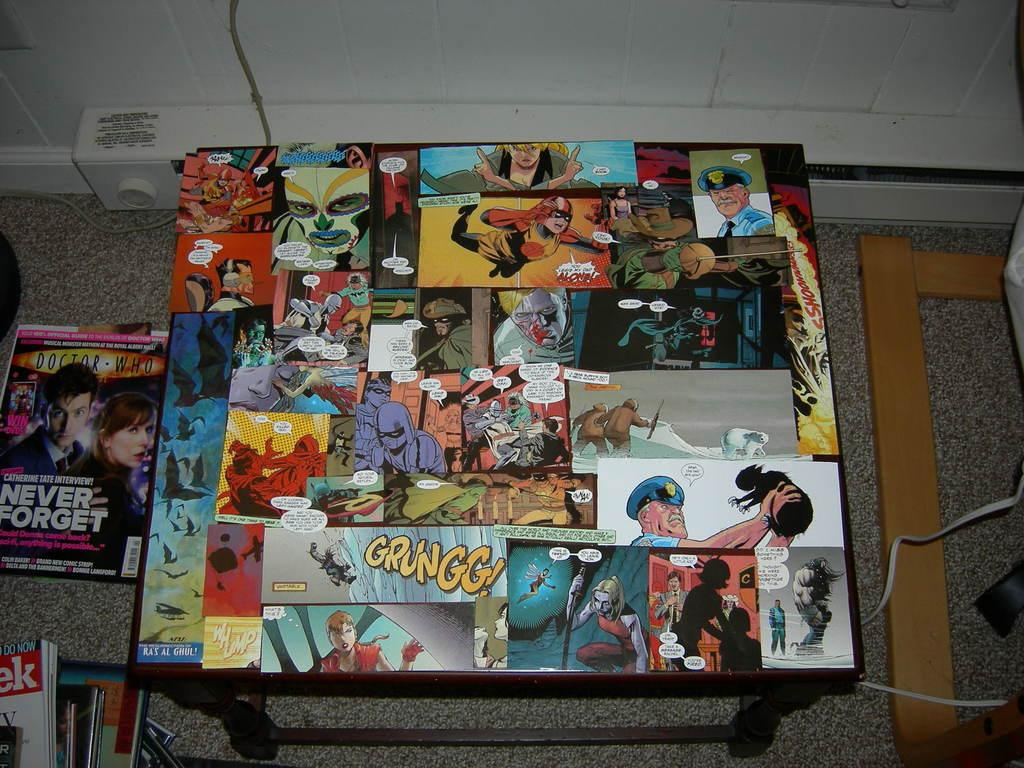What objects can be seen on the table in the image? There are posts on a table in the image. What type of items are present on the table or nearby? There are books in the image. What is located on the floor in the image? There is a wooden object and a cable on the floor in the image. What can be seen in the background of the image? There is a wall visible in the image. What is at the top of the image? There is an object at the top of the image. How many girls are spying on the wooden object in the image? There are no girls or spying activity present in the image. 